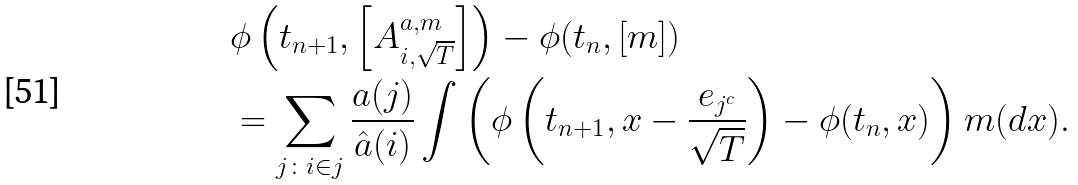<formula> <loc_0><loc_0><loc_500><loc_500>& \phi \left ( t _ { n + 1 } , \left [ A ^ { a , m } _ { i , \sqrt { T } } \right ] \right ) - \phi ( t _ { n } , [ m ] ) \\ & = \sum _ { j \colon i \in j } \frac { a ( j ) } { \hat { a } ( i ) } \int \left ( \phi \left ( t _ { n + 1 } , x - \frac { e _ { j ^ { c } } } { \sqrt { T } } \right ) - \phi ( t _ { n } , x ) \right ) m ( d x ) .</formula> 